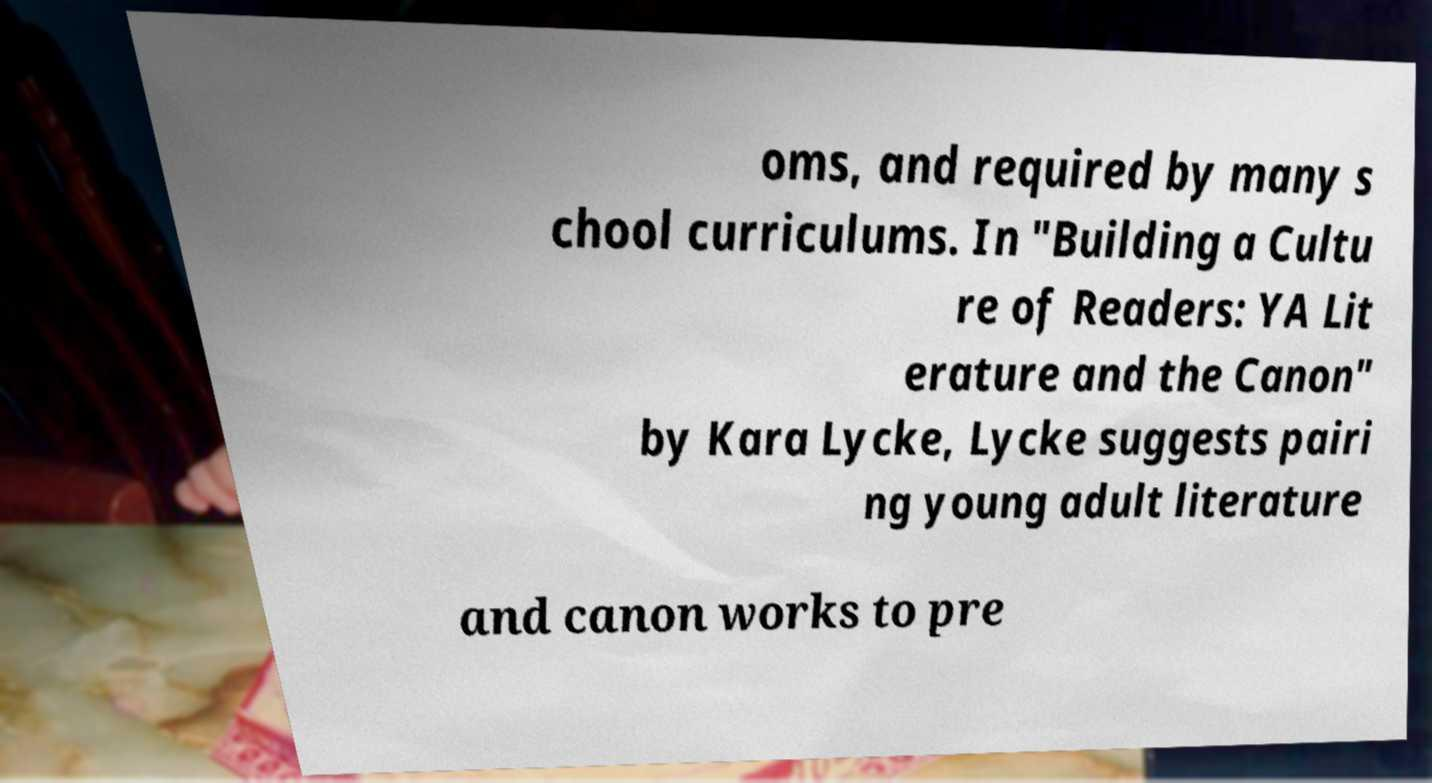Can you read and provide the text displayed in the image?This photo seems to have some interesting text. Can you extract and type it out for me? oms, and required by many s chool curriculums. In "Building a Cultu re of Readers: YA Lit erature and the Canon" by Kara Lycke, Lycke suggests pairi ng young adult literature and canon works to pre 